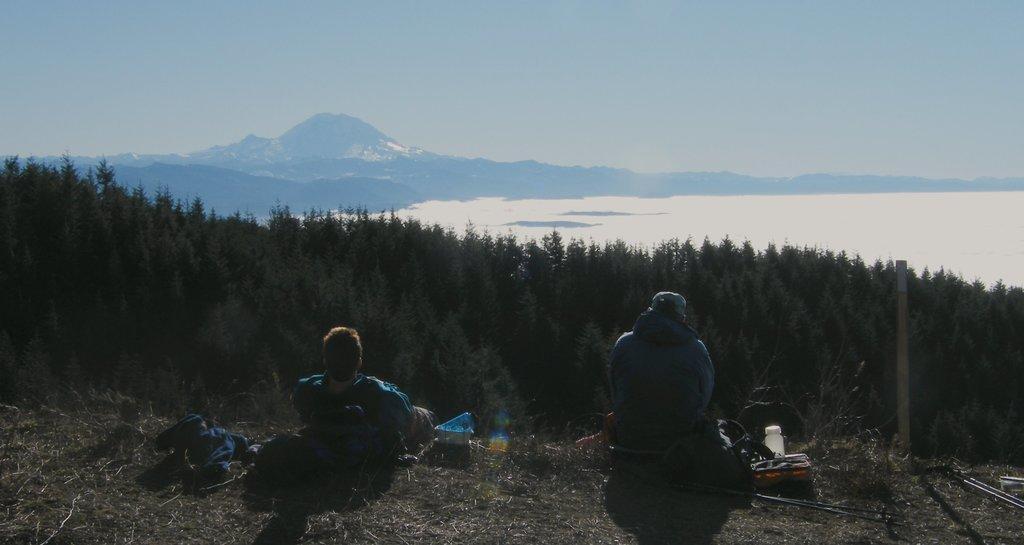Can you describe this image briefly? At the bottom of the image two persons are sitting and there are some boxes and bottles and bags. Behind them there are some trees. Behind the trees there is water and hills. At the top of the image there is sky. 